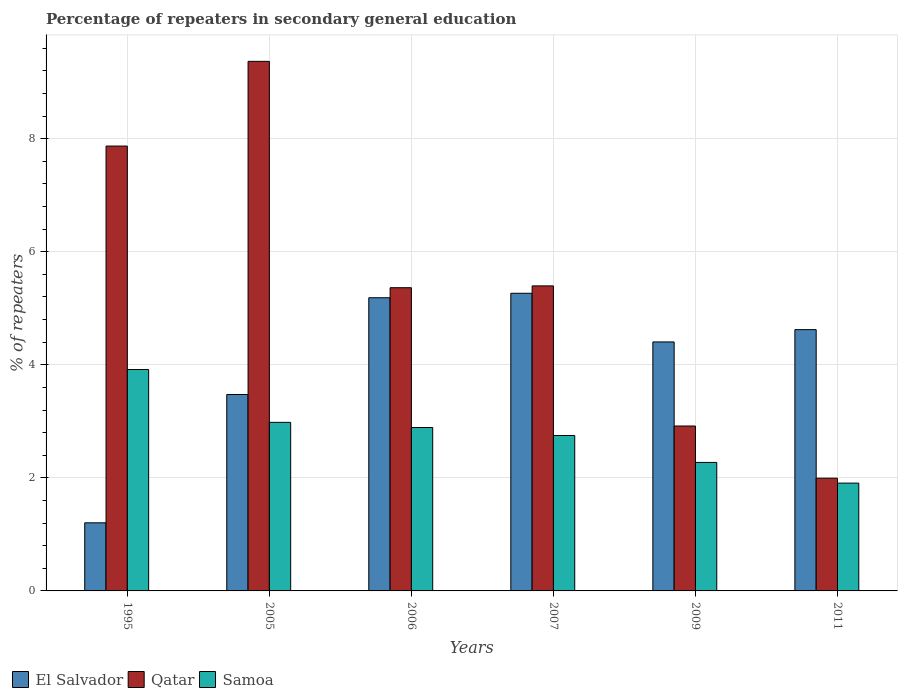Are the number of bars per tick equal to the number of legend labels?
Give a very brief answer. Yes. How many bars are there on the 4th tick from the left?
Ensure brevity in your answer.  3. How many bars are there on the 3rd tick from the right?
Your answer should be very brief. 3. What is the percentage of repeaters in secondary general education in Qatar in 2005?
Provide a short and direct response. 9.37. Across all years, what is the maximum percentage of repeaters in secondary general education in Qatar?
Keep it short and to the point. 9.37. Across all years, what is the minimum percentage of repeaters in secondary general education in Qatar?
Keep it short and to the point. 1.99. In which year was the percentage of repeaters in secondary general education in Samoa maximum?
Your answer should be very brief. 1995. What is the total percentage of repeaters in secondary general education in Samoa in the graph?
Your response must be concise. 16.72. What is the difference between the percentage of repeaters in secondary general education in Samoa in 1995 and that in 2007?
Your response must be concise. 1.17. What is the difference between the percentage of repeaters in secondary general education in Samoa in 2007 and the percentage of repeaters in secondary general education in El Salvador in 2011?
Offer a very short reply. -1.87. What is the average percentage of repeaters in secondary general education in El Salvador per year?
Your response must be concise. 4.03. In the year 2011, what is the difference between the percentage of repeaters in secondary general education in El Salvador and percentage of repeaters in secondary general education in Qatar?
Your answer should be very brief. 2.63. What is the ratio of the percentage of repeaters in secondary general education in Qatar in 2006 to that in 2009?
Give a very brief answer. 1.84. Is the difference between the percentage of repeaters in secondary general education in El Salvador in 2006 and 2009 greater than the difference between the percentage of repeaters in secondary general education in Qatar in 2006 and 2009?
Your response must be concise. No. What is the difference between the highest and the second highest percentage of repeaters in secondary general education in Qatar?
Make the answer very short. 1.5. What is the difference between the highest and the lowest percentage of repeaters in secondary general education in Qatar?
Give a very brief answer. 7.37. In how many years, is the percentage of repeaters in secondary general education in El Salvador greater than the average percentage of repeaters in secondary general education in El Salvador taken over all years?
Offer a very short reply. 4. What does the 3rd bar from the left in 2011 represents?
Make the answer very short. Samoa. What does the 3rd bar from the right in 2006 represents?
Ensure brevity in your answer.  El Salvador. Is it the case that in every year, the sum of the percentage of repeaters in secondary general education in Qatar and percentage of repeaters in secondary general education in El Salvador is greater than the percentage of repeaters in secondary general education in Samoa?
Provide a succinct answer. Yes. How many bars are there?
Your response must be concise. 18. Are all the bars in the graph horizontal?
Provide a succinct answer. No. Does the graph contain any zero values?
Your response must be concise. No. Where does the legend appear in the graph?
Offer a terse response. Bottom left. How many legend labels are there?
Provide a succinct answer. 3. What is the title of the graph?
Ensure brevity in your answer.  Percentage of repeaters in secondary general education. What is the label or title of the X-axis?
Your answer should be very brief. Years. What is the label or title of the Y-axis?
Make the answer very short. % of repeaters. What is the % of repeaters of El Salvador in 1995?
Your answer should be compact. 1.2. What is the % of repeaters in Qatar in 1995?
Provide a short and direct response. 7.87. What is the % of repeaters of Samoa in 1995?
Offer a terse response. 3.92. What is the % of repeaters of El Salvador in 2005?
Offer a very short reply. 3.47. What is the % of repeaters of Qatar in 2005?
Your answer should be compact. 9.37. What is the % of repeaters in Samoa in 2005?
Offer a terse response. 2.98. What is the % of repeaters in El Salvador in 2006?
Your response must be concise. 5.19. What is the % of repeaters in Qatar in 2006?
Your answer should be compact. 5.36. What is the % of repeaters in Samoa in 2006?
Give a very brief answer. 2.89. What is the % of repeaters in El Salvador in 2007?
Give a very brief answer. 5.27. What is the % of repeaters of Qatar in 2007?
Provide a succinct answer. 5.4. What is the % of repeaters in Samoa in 2007?
Your answer should be very brief. 2.75. What is the % of repeaters in El Salvador in 2009?
Provide a succinct answer. 4.4. What is the % of repeaters of Qatar in 2009?
Your answer should be very brief. 2.92. What is the % of repeaters in Samoa in 2009?
Provide a succinct answer. 2.27. What is the % of repeaters in El Salvador in 2011?
Provide a short and direct response. 4.62. What is the % of repeaters in Qatar in 2011?
Offer a very short reply. 1.99. What is the % of repeaters in Samoa in 2011?
Make the answer very short. 1.91. Across all years, what is the maximum % of repeaters of El Salvador?
Make the answer very short. 5.27. Across all years, what is the maximum % of repeaters in Qatar?
Ensure brevity in your answer.  9.37. Across all years, what is the maximum % of repeaters in Samoa?
Give a very brief answer. 3.92. Across all years, what is the minimum % of repeaters of El Salvador?
Provide a succinct answer. 1.2. Across all years, what is the minimum % of repeaters in Qatar?
Your answer should be very brief. 1.99. Across all years, what is the minimum % of repeaters of Samoa?
Offer a terse response. 1.91. What is the total % of repeaters of El Salvador in the graph?
Make the answer very short. 24.16. What is the total % of repeaters of Qatar in the graph?
Your answer should be very brief. 32.91. What is the total % of repeaters of Samoa in the graph?
Provide a short and direct response. 16.72. What is the difference between the % of repeaters in El Salvador in 1995 and that in 2005?
Keep it short and to the point. -2.27. What is the difference between the % of repeaters of Qatar in 1995 and that in 2005?
Your response must be concise. -1.5. What is the difference between the % of repeaters in Samoa in 1995 and that in 2005?
Your answer should be compact. 0.93. What is the difference between the % of repeaters of El Salvador in 1995 and that in 2006?
Ensure brevity in your answer.  -3.98. What is the difference between the % of repeaters of Qatar in 1995 and that in 2006?
Your answer should be compact. 2.51. What is the difference between the % of repeaters of El Salvador in 1995 and that in 2007?
Provide a short and direct response. -4.06. What is the difference between the % of repeaters in Qatar in 1995 and that in 2007?
Ensure brevity in your answer.  2.47. What is the difference between the % of repeaters of Samoa in 1995 and that in 2007?
Provide a short and direct response. 1.17. What is the difference between the % of repeaters of El Salvador in 1995 and that in 2009?
Make the answer very short. -3.2. What is the difference between the % of repeaters of Qatar in 1995 and that in 2009?
Give a very brief answer. 4.95. What is the difference between the % of repeaters of Samoa in 1995 and that in 2009?
Give a very brief answer. 1.64. What is the difference between the % of repeaters in El Salvador in 1995 and that in 2011?
Ensure brevity in your answer.  -3.42. What is the difference between the % of repeaters of Qatar in 1995 and that in 2011?
Keep it short and to the point. 5.88. What is the difference between the % of repeaters of Samoa in 1995 and that in 2011?
Give a very brief answer. 2.01. What is the difference between the % of repeaters in El Salvador in 2005 and that in 2006?
Provide a succinct answer. -1.71. What is the difference between the % of repeaters of Qatar in 2005 and that in 2006?
Keep it short and to the point. 4. What is the difference between the % of repeaters of Samoa in 2005 and that in 2006?
Provide a short and direct response. 0.09. What is the difference between the % of repeaters in El Salvador in 2005 and that in 2007?
Provide a short and direct response. -1.79. What is the difference between the % of repeaters of Qatar in 2005 and that in 2007?
Offer a terse response. 3.97. What is the difference between the % of repeaters of Samoa in 2005 and that in 2007?
Provide a short and direct response. 0.23. What is the difference between the % of repeaters of El Salvador in 2005 and that in 2009?
Provide a succinct answer. -0.93. What is the difference between the % of repeaters in Qatar in 2005 and that in 2009?
Your answer should be very brief. 6.45. What is the difference between the % of repeaters of Samoa in 2005 and that in 2009?
Your answer should be very brief. 0.71. What is the difference between the % of repeaters of El Salvador in 2005 and that in 2011?
Your answer should be very brief. -1.15. What is the difference between the % of repeaters in Qatar in 2005 and that in 2011?
Give a very brief answer. 7.37. What is the difference between the % of repeaters in Samoa in 2005 and that in 2011?
Your answer should be compact. 1.07. What is the difference between the % of repeaters in El Salvador in 2006 and that in 2007?
Keep it short and to the point. -0.08. What is the difference between the % of repeaters of Qatar in 2006 and that in 2007?
Ensure brevity in your answer.  -0.03. What is the difference between the % of repeaters in Samoa in 2006 and that in 2007?
Your response must be concise. 0.14. What is the difference between the % of repeaters in El Salvador in 2006 and that in 2009?
Your answer should be very brief. 0.78. What is the difference between the % of repeaters in Qatar in 2006 and that in 2009?
Keep it short and to the point. 2.45. What is the difference between the % of repeaters in Samoa in 2006 and that in 2009?
Your answer should be compact. 0.62. What is the difference between the % of repeaters in El Salvador in 2006 and that in 2011?
Provide a short and direct response. 0.56. What is the difference between the % of repeaters in Qatar in 2006 and that in 2011?
Give a very brief answer. 3.37. What is the difference between the % of repeaters of Samoa in 2006 and that in 2011?
Provide a short and direct response. 0.98. What is the difference between the % of repeaters in El Salvador in 2007 and that in 2009?
Provide a short and direct response. 0.86. What is the difference between the % of repeaters in Qatar in 2007 and that in 2009?
Offer a very short reply. 2.48. What is the difference between the % of repeaters of Samoa in 2007 and that in 2009?
Give a very brief answer. 0.48. What is the difference between the % of repeaters of El Salvador in 2007 and that in 2011?
Give a very brief answer. 0.64. What is the difference between the % of repeaters in Qatar in 2007 and that in 2011?
Keep it short and to the point. 3.4. What is the difference between the % of repeaters of Samoa in 2007 and that in 2011?
Provide a short and direct response. 0.84. What is the difference between the % of repeaters of El Salvador in 2009 and that in 2011?
Keep it short and to the point. -0.22. What is the difference between the % of repeaters in Qatar in 2009 and that in 2011?
Provide a succinct answer. 0.92. What is the difference between the % of repeaters in Samoa in 2009 and that in 2011?
Ensure brevity in your answer.  0.37. What is the difference between the % of repeaters of El Salvador in 1995 and the % of repeaters of Qatar in 2005?
Your answer should be very brief. -8.16. What is the difference between the % of repeaters of El Salvador in 1995 and the % of repeaters of Samoa in 2005?
Your answer should be very brief. -1.78. What is the difference between the % of repeaters in Qatar in 1995 and the % of repeaters in Samoa in 2005?
Provide a short and direct response. 4.89. What is the difference between the % of repeaters of El Salvador in 1995 and the % of repeaters of Qatar in 2006?
Ensure brevity in your answer.  -4.16. What is the difference between the % of repeaters in El Salvador in 1995 and the % of repeaters in Samoa in 2006?
Offer a very short reply. -1.69. What is the difference between the % of repeaters of Qatar in 1995 and the % of repeaters of Samoa in 2006?
Provide a short and direct response. 4.98. What is the difference between the % of repeaters in El Salvador in 1995 and the % of repeaters in Qatar in 2007?
Your answer should be very brief. -4.19. What is the difference between the % of repeaters in El Salvador in 1995 and the % of repeaters in Samoa in 2007?
Offer a very short reply. -1.54. What is the difference between the % of repeaters in Qatar in 1995 and the % of repeaters in Samoa in 2007?
Your answer should be compact. 5.12. What is the difference between the % of repeaters in El Salvador in 1995 and the % of repeaters in Qatar in 2009?
Keep it short and to the point. -1.71. What is the difference between the % of repeaters in El Salvador in 1995 and the % of repeaters in Samoa in 2009?
Provide a short and direct response. -1.07. What is the difference between the % of repeaters of Qatar in 1995 and the % of repeaters of Samoa in 2009?
Ensure brevity in your answer.  5.6. What is the difference between the % of repeaters in El Salvador in 1995 and the % of repeaters in Qatar in 2011?
Make the answer very short. -0.79. What is the difference between the % of repeaters in El Salvador in 1995 and the % of repeaters in Samoa in 2011?
Offer a terse response. -0.7. What is the difference between the % of repeaters in Qatar in 1995 and the % of repeaters in Samoa in 2011?
Make the answer very short. 5.96. What is the difference between the % of repeaters in El Salvador in 2005 and the % of repeaters in Qatar in 2006?
Give a very brief answer. -1.89. What is the difference between the % of repeaters of El Salvador in 2005 and the % of repeaters of Samoa in 2006?
Your answer should be very brief. 0.58. What is the difference between the % of repeaters of Qatar in 2005 and the % of repeaters of Samoa in 2006?
Give a very brief answer. 6.48. What is the difference between the % of repeaters in El Salvador in 2005 and the % of repeaters in Qatar in 2007?
Provide a succinct answer. -1.92. What is the difference between the % of repeaters of El Salvador in 2005 and the % of repeaters of Samoa in 2007?
Your answer should be very brief. 0.73. What is the difference between the % of repeaters of Qatar in 2005 and the % of repeaters of Samoa in 2007?
Keep it short and to the point. 6.62. What is the difference between the % of repeaters in El Salvador in 2005 and the % of repeaters in Qatar in 2009?
Your answer should be compact. 0.56. What is the difference between the % of repeaters in El Salvador in 2005 and the % of repeaters in Samoa in 2009?
Ensure brevity in your answer.  1.2. What is the difference between the % of repeaters in Qatar in 2005 and the % of repeaters in Samoa in 2009?
Offer a terse response. 7.1. What is the difference between the % of repeaters of El Salvador in 2005 and the % of repeaters of Qatar in 2011?
Ensure brevity in your answer.  1.48. What is the difference between the % of repeaters in El Salvador in 2005 and the % of repeaters in Samoa in 2011?
Provide a succinct answer. 1.57. What is the difference between the % of repeaters in Qatar in 2005 and the % of repeaters in Samoa in 2011?
Your answer should be compact. 7.46. What is the difference between the % of repeaters of El Salvador in 2006 and the % of repeaters of Qatar in 2007?
Your answer should be compact. -0.21. What is the difference between the % of repeaters in El Salvador in 2006 and the % of repeaters in Samoa in 2007?
Give a very brief answer. 2.44. What is the difference between the % of repeaters in Qatar in 2006 and the % of repeaters in Samoa in 2007?
Provide a short and direct response. 2.61. What is the difference between the % of repeaters of El Salvador in 2006 and the % of repeaters of Qatar in 2009?
Offer a very short reply. 2.27. What is the difference between the % of repeaters in El Salvador in 2006 and the % of repeaters in Samoa in 2009?
Keep it short and to the point. 2.91. What is the difference between the % of repeaters in Qatar in 2006 and the % of repeaters in Samoa in 2009?
Your answer should be very brief. 3.09. What is the difference between the % of repeaters of El Salvador in 2006 and the % of repeaters of Qatar in 2011?
Your response must be concise. 3.19. What is the difference between the % of repeaters of El Salvador in 2006 and the % of repeaters of Samoa in 2011?
Keep it short and to the point. 3.28. What is the difference between the % of repeaters of Qatar in 2006 and the % of repeaters of Samoa in 2011?
Your answer should be very brief. 3.46. What is the difference between the % of repeaters in El Salvador in 2007 and the % of repeaters in Qatar in 2009?
Provide a succinct answer. 2.35. What is the difference between the % of repeaters of El Salvador in 2007 and the % of repeaters of Samoa in 2009?
Keep it short and to the point. 2.99. What is the difference between the % of repeaters in Qatar in 2007 and the % of repeaters in Samoa in 2009?
Provide a succinct answer. 3.12. What is the difference between the % of repeaters in El Salvador in 2007 and the % of repeaters in Qatar in 2011?
Your response must be concise. 3.27. What is the difference between the % of repeaters in El Salvador in 2007 and the % of repeaters in Samoa in 2011?
Provide a succinct answer. 3.36. What is the difference between the % of repeaters of Qatar in 2007 and the % of repeaters of Samoa in 2011?
Offer a terse response. 3.49. What is the difference between the % of repeaters of El Salvador in 2009 and the % of repeaters of Qatar in 2011?
Keep it short and to the point. 2.41. What is the difference between the % of repeaters of El Salvador in 2009 and the % of repeaters of Samoa in 2011?
Ensure brevity in your answer.  2.5. What is the difference between the % of repeaters in Qatar in 2009 and the % of repeaters in Samoa in 2011?
Your response must be concise. 1.01. What is the average % of repeaters in El Salvador per year?
Offer a very short reply. 4.03. What is the average % of repeaters of Qatar per year?
Make the answer very short. 5.49. What is the average % of repeaters of Samoa per year?
Your response must be concise. 2.79. In the year 1995, what is the difference between the % of repeaters in El Salvador and % of repeaters in Qatar?
Offer a terse response. -6.67. In the year 1995, what is the difference between the % of repeaters in El Salvador and % of repeaters in Samoa?
Ensure brevity in your answer.  -2.71. In the year 1995, what is the difference between the % of repeaters in Qatar and % of repeaters in Samoa?
Your answer should be very brief. 3.95. In the year 2005, what is the difference between the % of repeaters in El Salvador and % of repeaters in Qatar?
Provide a succinct answer. -5.89. In the year 2005, what is the difference between the % of repeaters in El Salvador and % of repeaters in Samoa?
Your response must be concise. 0.49. In the year 2005, what is the difference between the % of repeaters in Qatar and % of repeaters in Samoa?
Ensure brevity in your answer.  6.39. In the year 2006, what is the difference between the % of repeaters of El Salvador and % of repeaters of Qatar?
Ensure brevity in your answer.  -0.18. In the year 2006, what is the difference between the % of repeaters of El Salvador and % of repeaters of Samoa?
Give a very brief answer. 2.3. In the year 2006, what is the difference between the % of repeaters of Qatar and % of repeaters of Samoa?
Provide a succinct answer. 2.47. In the year 2007, what is the difference between the % of repeaters of El Salvador and % of repeaters of Qatar?
Offer a very short reply. -0.13. In the year 2007, what is the difference between the % of repeaters in El Salvador and % of repeaters in Samoa?
Give a very brief answer. 2.52. In the year 2007, what is the difference between the % of repeaters of Qatar and % of repeaters of Samoa?
Your answer should be compact. 2.65. In the year 2009, what is the difference between the % of repeaters in El Salvador and % of repeaters in Qatar?
Your answer should be very brief. 1.49. In the year 2009, what is the difference between the % of repeaters of El Salvador and % of repeaters of Samoa?
Give a very brief answer. 2.13. In the year 2009, what is the difference between the % of repeaters of Qatar and % of repeaters of Samoa?
Give a very brief answer. 0.64. In the year 2011, what is the difference between the % of repeaters in El Salvador and % of repeaters in Qatar?
Give a very brief answer. 2.63. In the year 2011, what is the difference between the % of repeaters of El Salvador and % of repeaters of Samoa?
Offer a terse response. 2.72. In the year 2011, what is the difference between the % of repeaters in Qatar and % of repeaters in Samoa?
Make the answer very short. 0.09. What is the ratio of the % of repeaters in El Salvador in 1995 to that in 2005?
Provide a succinct answer. 0.35. What is the ratio of the % of repeaters in Qatar in 1995 to that in 2005?
Your answer should be compact. 0.84. What is the ratio of the % of repeaters of Samoa in 1995 to that in 2005?
Offer a terse response. 1.31. What is the ratio of the % of repeaters in El Salvador in 1995 to that in 2006?
Your answer should be very brief. 0.23. What is the ratio of the % of repeaters in Qatar in 1995 to that in 2006?
Offer a very short reply. 1.47. What is the ratio of the % of repeaters in Samoa in 1995 to that in 2006?
Your answer should be very brief. 1.35. What is the ratio of the % of repeaters in El Salvador in 1995 to that in 2007?
Make the answer very short. 0.23. What is the ratio of the % of repeaters of Qatar in 1995 to that in 2007?
Your response must be concise. 1.46. What is the ratio of the % of repeaters of Samoa in 1995 to that in 2007?
Your answer should be very brief. 1.42. What is the ratio of the % of repeaters in El Salvador in 1995 to that in 2009?
Offer a terse response. 0.27. What is the ratio of the % of repeaters of Qatar in 1995 to that in 2009?
Give a very brief answer. 2.7. What is the ratio of the % of repeaters in Samoa in 1995 to that in 2009?
Your response must be concise. 1.72. What is the ratio of the % of repeaters in El Salvador in 1995 to that in 2011?
Keep it short and to the point. 0.26. What is the ratio of the % of repeaters in Qatar in 1995 to that in 2011?
Ensure brevity in your answer.  3.95. What is the ratio of the % of repeaters in Samoa in 1995 to that in 2011?
Offer a terse response. 2.05. What is the ratio of the % of repeaters in El Salvador in 2005 to that in 2006?
Your answer should be compact. 0.67. What is the ratio of the % of repeaters in Qatar in 2005 to that in 2006?
Your answer should be very brief. 1.75. What is the ratio of the % of repeaters in Samoa in 2005 to that in 2006?
Ensure brevity in your answer.  1.03. What is the ratio of the % of repeaters of El Salvador in 2005 to that in 2007?
Provide a short and direct response. 0.66. What is the ratio of the % of repeaters of Qatar in 2005 to that in 2007?
Give a very brief answer. 1.74. What is the ratio of the % of repeaters in Samoa in 2005 to that in 2007?
Make the answer very short. 1.08. What is the ratio of the % of repeaters of El Salvador in 2005 to that in 2009?
Offer a very short reply. 0.79. What is the ratio of the % of repeaters in Qatar in 2005 to that in 2009?
Your answer should be very brief. 3.21. What is the ratio of the % of repeaters of Samoa in 2005 to that in 2009?
Your response must be concise. 1.31. What is the ratio of the % of repeaters of El Salvador in 2005 to that in 2011?
Your answer should be very brief. 0.75. What is the ratio of the % of repeaters in Qatar in 2005 to that in 2011?
Provide a succinct answer. 4.7. What is the ratio of the % of repeaters of Samoa in 2005 to that in 2011?
Ensure brevity in your answer.  1.56. What is the ratio of the % of repeaters in El Salvador in 2006 to that in 2007?
Make the answer very short. 0.98. What is the ratio of the % of repeaters of Qatar in 2006 to that in 2007?
Provide a succinct answer. 0.99. What is the ratio of the % of repeaters in Samoa in 2006 to that in 2007?
Make the answer very short. 1.05. What is the ratio of the % of repeaters in El Salvador in 2006 to that in 2009?
Ensure brevity in your answer.  1.18. What is the ratio of the % of repeaters in Qatar in 2006 to that in 2009?
Your answer should be very brief. 1.84. What is the ratio of the % of repeaters in Samoa in 2006 to that in 2009?
Offer a very short reply. 1.27. What is the ratio of the % of repeaters of El Salvador in 2006 to that in 2011?
Ensure brevity in your answer.  1.12. What is the ratio of the % of repeaters in Qatar in 2006 to that in 2011?
Your answer should be compact. 2.69. What is the ratio of the % of repeaters in Samoa in 2006 to that in 2011?
Provide a short and direct response. 1.52. What is the ratio of the % of repeaters of El Salvador in 2007 to that in 2009?
Your response must be concise. 1.2. What is the ratio of the % of repeaters of Qatar in 2007 to that in 2009?
Your answer should be very brief. 1.85. What is the ratio of the % of repeaters in Samoa in 2007 to that in 2009?
Your answer should be compact. 1.21. What is the ratio of the % of repeaters in El Salvador in 2007 to that in 2011?
Your answer should be very brief. 1.14. What is the ratio of the % of repeaters of Qatar in 2007 to that in 2011?
Provide a short and direct response. 2.71. What is the ratio of the % of repeaters of Samoa in 2007 to that in 2011?
Ensure brevity in your answer.  1.44. What is the ratio of the % of repeaters of El Salvador in 2009 to that in 2011?
Your answer should be compact. 0.95. What is the ratio of the % of repeaters in Qatar in 2009 to that in 2011?
Provide a short and direct response. 1.46. What is the ratio of the % of repeaters of Samoa in 2009 to that in 2011?
Give a very brief answer. 1.19. What is the difference between the highest and the second highest % of repeaters of El Salvador?
Your answer should be compact. 0.08. What is the difference between the highest and the second highest % of repeaters in Qatar?
Your response must be concise. 1.5. What is the difference between the highest and the second highest % of repeaters of Samoa?
Provide a succinct answer. 0.93. What is the difference between the highest and the lowest % of repeaters of El Salvador?
Provide a short and direct response. 4.06. What is the difference between the highest and the lowest % of repeaters of Qatar?
Make the answer very short. 7.37. What is the difference between the highest and the lowest % of repeaters of Samoa?
Keep it short and to the point. 2.01. 